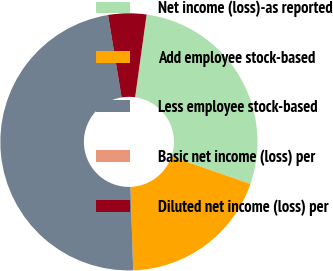<chart> <loc_0><loc_0><loc_500><loc_500><pie_chart><fcel>Net income (loss)-as reported<fcel>Add employee stock-based<fcel>Less employee stock-based<fcel>Basic net income (loss) per<fcel>Diluted net income (loss) per<nl><fcel>28.1%<fcel>19.17%<fcel>47.94%<fcel>0.0%<fcel>4.79%<nl></chart> 